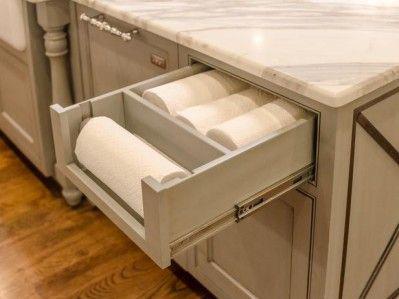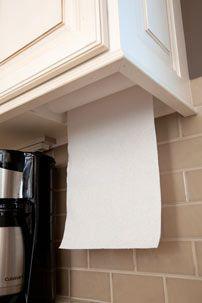The first image is the image on the left, the second image is the image on the right. Examine the images to the left and right. Is the description "An image shows a roll of towels suspended on a chrome wire bar mounted on the underside of a surface." accurate? Answer yes or no. No. The first image is the image on the left, the second image is the image on the right. For the images shown, is this caption "The paper towels on the left are hanging under a cabinet." true? Answer yes or no. No. 